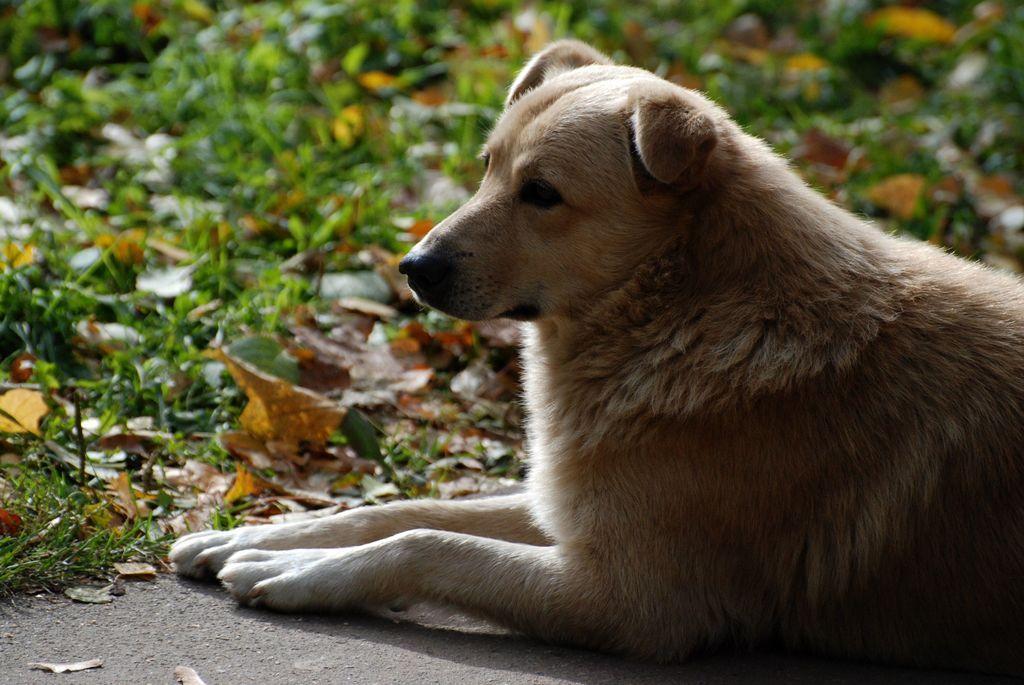Could you give a brief overview of what you see in this image? In this picture I can see there is a dog and it is looking at left side and there is grass, dry leaves and soil on the floor. 